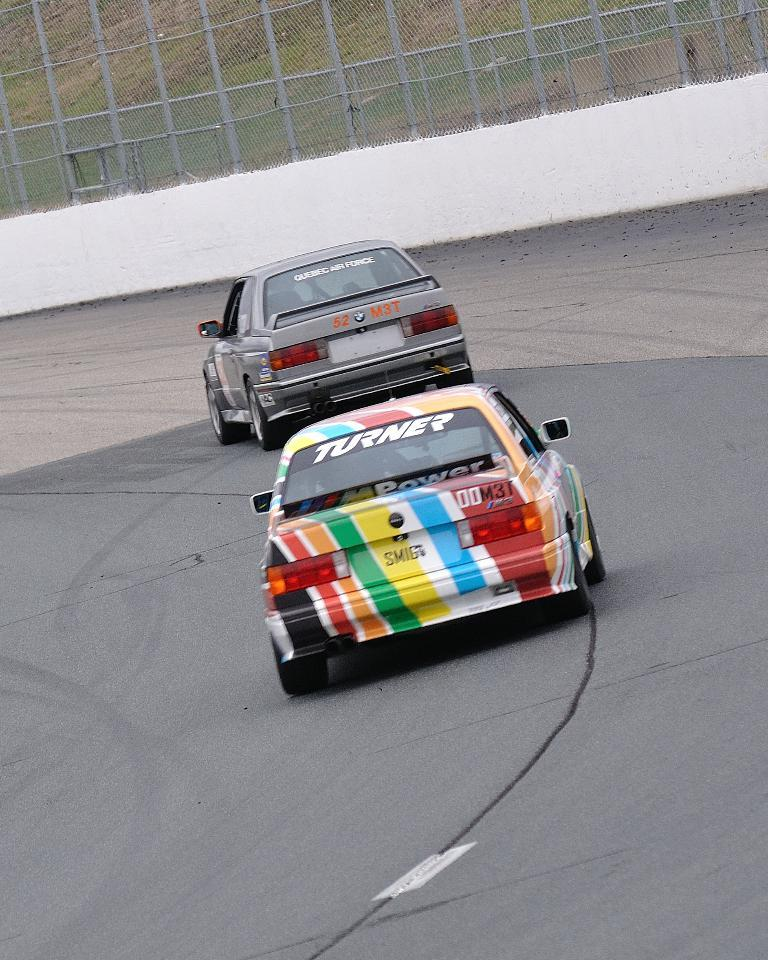How many cars are visible on the road in the image? There are two cars on the road in the image. What can be seen in the background of the image? There are poles on a platform and a fence in the background. What type of vegetation is present on the ground in the background? Grass is present on the ground in the background. What type of hobbies are the cars participating in during the image? Cars do not have hobbies, as they are inanimate objects. The image simply shows two cars on the road. 